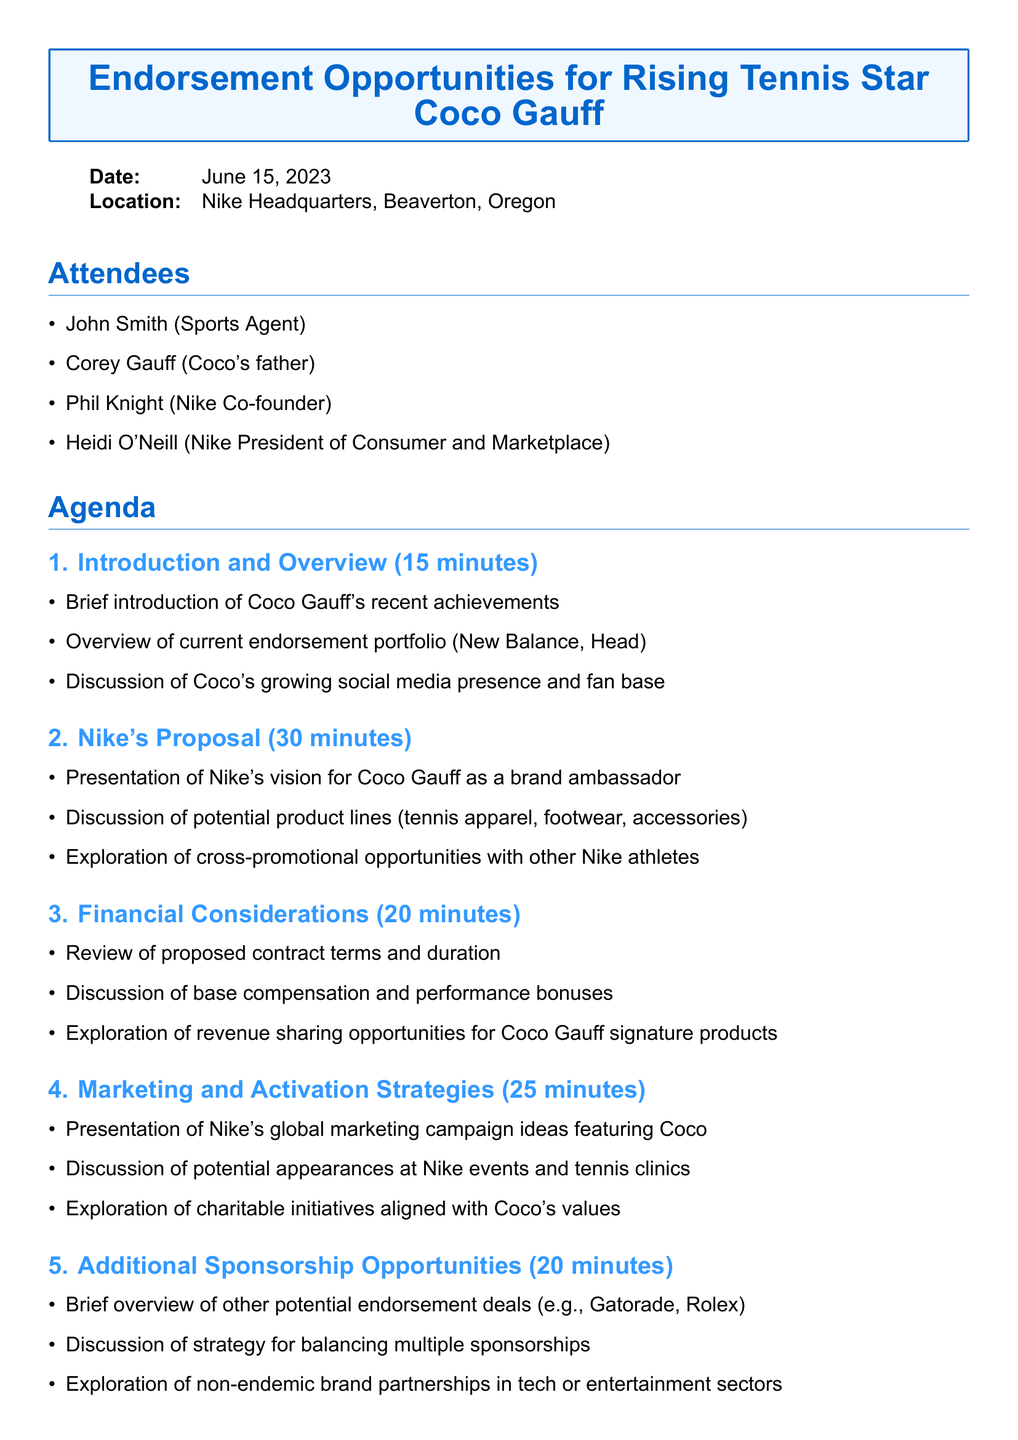What is the meeting title? The meeting title is the title given at the beginning of the agenda document, which summarizes the purpose of the meeting.
Answer: Endorsement Opportunities for Rising Tennis Star Coco Gauff Who are the attendees? The attendees list comprises key participants in the meeting mentioned in the document.
Answer: John Smith, Corey Gauff, Phil Knight, Heidi O'Neill What is the date of the meeting? The document specifies the exact date when the meeting is scheduled to take place.
Answer: June 15, 2023 How long is the Nike's proposal section? The document states the duration allocated for the Nike's proposal topic in the agenda.
Answer: 30 minutes What potential brands are discussed for additional sponsorship opportunities? The document provides a brief overview of other brands mentioned as potential endorsements during the meeting.
Answer: Gatorade, Rolex What is included in the additional notes section? The additional notes section lists supportive information meant for the attendees to consider before the meeting.
Answer: Bring latest performance statistics and media coverage reports, prepare questions about Nike's support for young athletes' education and well-being, discuss potential conflicts with existing sponsorship agreements What is the main focus of the Financial Considerations topic? The Financial Considerations topic in the agenda specifically addresses the economic aspects of the endorsement deal.
Answer: Review of proposed contract terms and duration, base compensation and performance bonuses, revenue sharing opportunities What is the estimated time for the Next Steps and Action Items? The agenda outlines the duration allotted for discussing next steps and action items at the end of the meeting.
Answer: 10 minutes 